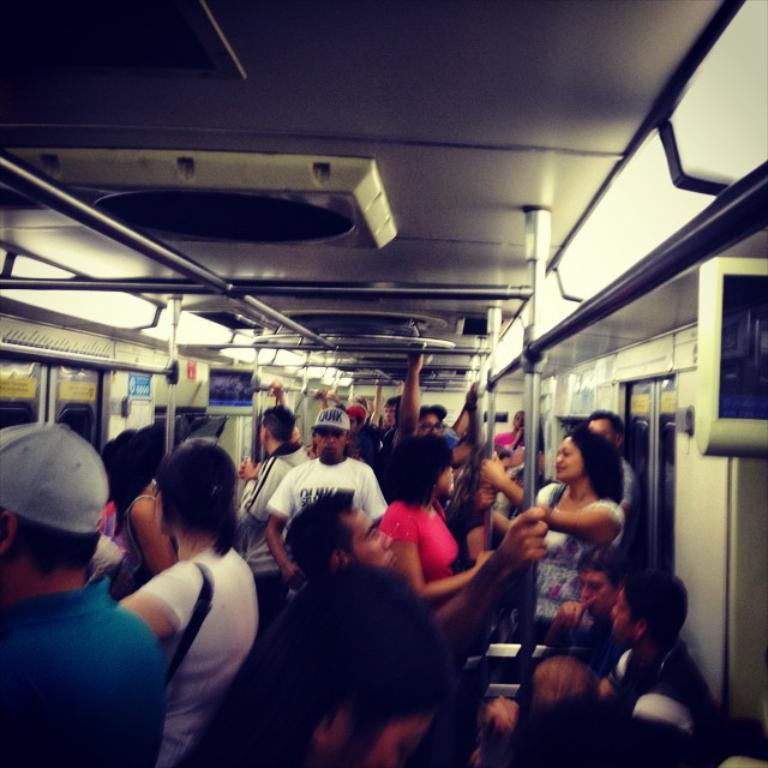Where is the image taken? The image is inside a train. What are the people in the image doing? Some people are standing, some are sitting, and some are holding iron bars. What are the people wearing? Some people are wearing caps. What can be seen in the background of the image? There are iron bars and doors visible in the image. What type of locket can be seen hanging from the iron bars in the image? There is no locket present in the image; it only features people, iron bars, and doors. 